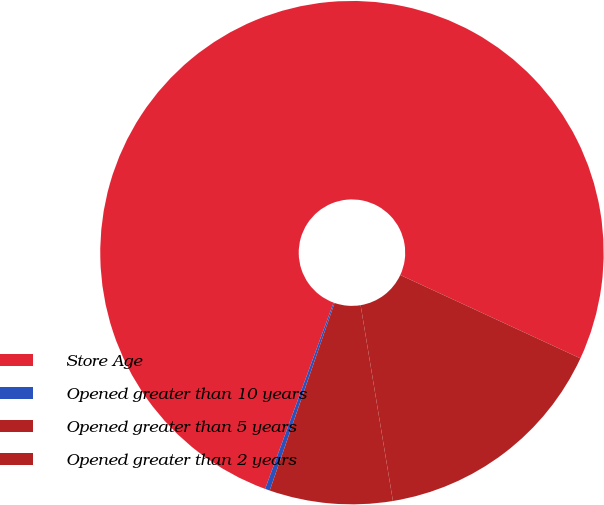Convert chart to OTSL. <chart><loc_0><loc_0><loc_500><loc_500><pie_chart><fcel>Store Age<fcel>Opened greater than 10 years<fcel>Opened greater than 5 years<fcel>Opened greater than 2 years<nl><fcel>76.29%<fcel>0.31%<fcel>7.9%<fcel>15.5%<nl></chart> 